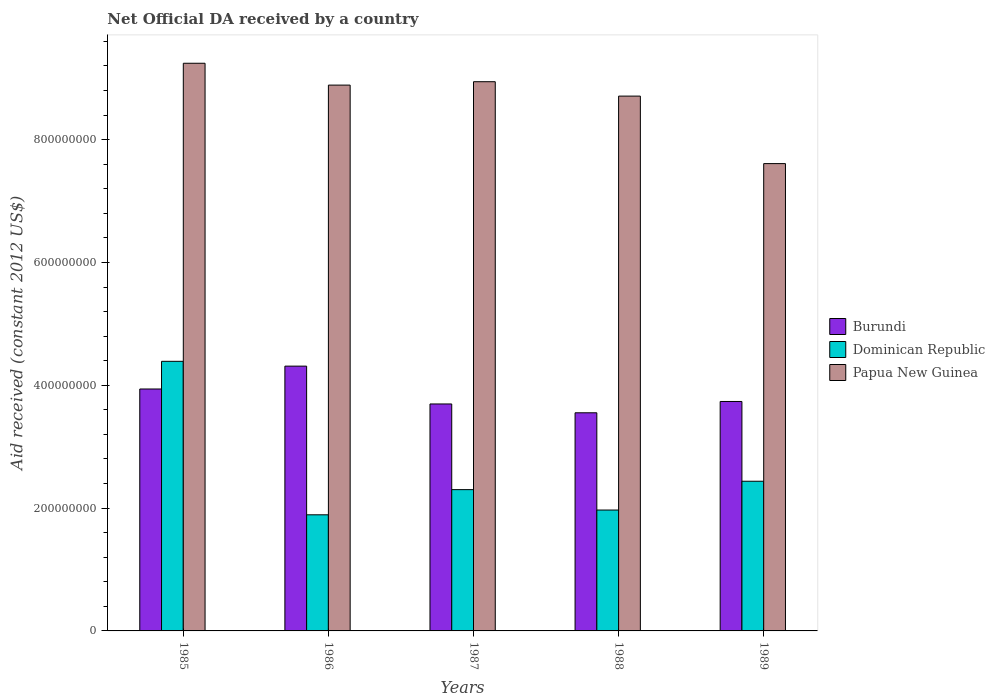How many different coloured bars are there?
Your answer should be compact. 3. How many groups of bars are there?
Provide a succinct answer. 5. How many bars are there on the 5th tick from the right?
Your response must be concise. 3. In how many cases, is the number of bars for a given year not equal to the number of legend labels?
Give a very brief answer. 0. What is the net official development assistance aid received in Dominican Republic in 1987?
Provide a short and direct response. 2.30e+08. Across all years, what is the maximum net official development assistance aid received in Dominican Republic?
Give a very brief answer. 4.39e+08. Across all years, what is the minimum net official development assistance aid received in Papua New Guinea?
Your response must be concise. 7.61e+08. In which year was the net official development assistance aid received in Papua New Guinea maximum?
Offer a terse response. 1985. In which year was the net official development assistance aid received in Dominican Republic minimum?
Keep it short and to the point. 1986. What is the total net official development assistance aid received in Papua New Guinea in the graph?
Your answer should be very brief. 4.34e+09. What is the difference between the net official development assistance aid received in Dominican Republic in 1985 and that in 1989?
Offer a terse response. 1.95e+08. What is the difference between the net official development assistance aid received in Papua New Guinea in 1988 and the net official development assistance aid received in Dominican Republic in 1989?
Provide a succinct answer. 6.27e+08. What is the average net official development assistance aid received in Dominican Republic per year?
Make the answer very short. 2.60e+08. In the year 1989, what is the difference between the net official development assistance aid received in Burundi and net official development assistance aid received in Dominican Republic?
Ensure brevity in your answer.  1.30e+08. What is the ratio of the net official development assistance aid received in Burundi in 1986 to that in 1987?
Your answer should be very brief. 1.17. Is the difference between the net official development assistance aid received in Burundi in 1986 and 1988 greater than the difference between the net official development assistance aid received in Dominican Republic in 1986 and 1988?
Your response must be concise. Yes. What is the difference between the highest and the second highest net official development assistance aid received in Papua New Guinea?
Offer a terse response. 3.00e+07. What is the difference between the highest and the lowest net official development assistance aid received in Dominican Republic?
Give a very brief answer. 2.50e+08. In how many years, is the net official development assistance aid received in Dominican Republic greater than the average net official development assistance aid received in Dominican Republic taken over all years?
Give a very brief answer. 1. What does the 1st bar from the left in 1985 represents?
Make the answer very short. Burundi. What does the 1st bar from the right in 1985 represents?
Offer a very short reply. Papua New Guinea. Is it the case that in every year, the sum of the net official development assistance aid received in Papua New Guinea and net official development assistance aid received in Dominican Republic is greater than the net official development assistance aid received in Burundi?
Give a very brief answer. Yes. How many bars are there?
Make the answer very short. 15. Are all the bars in the graph horizontal?
Your response must be concise. No. What is the difference between two consecutive major ticks on the Y-axis?
Keep it short and to the point. 2.00e+08. Does the graph contain any zero values?
Provide a succinct answer. No. Does the graph contain grids?
Your response must be concise. No. Where does the legend appear in the graph?
Keep it short and to the point. Center right. How are the legend labels stacked?
Offer a terse response. Vertical. What is the title of the graph?
Offer a very short reply. Net Official DA received by a country. What is the label or title of the X-axis?
Make the answer very short. Years. What is the label or title of the Y-axis?
Your answer should be very brief. Aid received (constant 2012 US$). What is the Aid received (constant 2012 US$) in Burundi in 1985?
Your response must be concise. 3.94e+08. What is the Aid received (constant 2012 US$) of Dominican Republic in 1985?
Provide a short and direct response. 4.39e+08. What is the Aid received (constant 2012 US$) of Papua New Guinea in 1985?
Provide a succinct answer. 9.24e+08. What is the Aid received (constant 2012 US$) in Burundi in 1986?
Provide a succinct answer. 4.31e+08. What is the Aid received (constant 2012 US$) in Dominican Republic in 1986?
Offer a terse response. 1.89e+08. What is the Aid received (constant 2012 US$) of Papua New Guinea in 1986?
Your response must be concise. 8.89e+08. What is the Aid received (constant 2012 US$) of Burundi in 1987?
Provide a succinct answer. 3.70e+08. What is the Aid received (constant 2012 US$) of Dominican Republic in 1987?
Make the answer very short. 2.30e+08. What is the Aid received (constant 2012 US$) of Papua New Guinea in 1987?
Provide a short and direct response. 8.94e+08. What is the Aid received (constant 2012 US$) of Burundi in 1988?
Ensure brevity in your answer.  3.55e+08. What is the Aid received (constant 2012 US$) of Dominican Republic in 1988?
Your response must be concise. 1.97e+08. What is the Aid received (constant 2012 US$) of Papua New Guinea in 1988?
Offer a terse response. 8.71e+08. What is the Aid received (constant 2012 US$) in Burundi in 1989?
Keep it short and to the point. 3.74e+08. What is the Aid received (constant 2012 US$) of Dominican Republic in 1989?
Offer a very short reply. 2.44e+08. What is the Aid received (constant 2012 US$) of Papua New Guinea in 1989?
Your answer should be compact. 7.61e+08. Across all years, what is the maximum Aid received (constant 2012 US$) of Burundi?
Your answer should be very brief. 4.31e+08. Across all years, what is the maximum Aid received (constant 2012 US$) in Dominican Republic?
Give a very brief answer. 4.39e+08. Across all years, what is the maximum Aid received (constant 2012 US$) of Papua New Guinea?
Provide a succinct answer. 9.24e+08. Across all years, what is the minimum Aid received (constant 2012 US$) of Burundi?
Your answer should be very brief. 3.55e+08. Across all years, what is the minimum Aid received (constant 2012 US$) of Dominican Republic?
Provide a short and direct response. 1.89e+08. Across all years, what is the minimum Aid received (constant 2012 US$) of Papua New Guinea?
Your response must be concise. 7.61e+08. What is the total Aid received (constant 2012 US$) of Burundi in the graph?
Offer a very short reply. 1.92e+09. What is the total Aid received (constant 2012 US$) of Dominican Republic in the graph?
Provide a succinct answer. 1.30e+09. What is the total Aid received (constant 2012 US$) of Papua New Guinea in the graph?
Ensure brevity in your answer.  4.34e+09. What is the difference between the Aid received (constant 2012 US$) in Burundi in 1985 and that in 1986?
Offer a terse response. -3.72e+07. What is the difference between the Aid received (constant 2012 US$) of Dominican Republic in 1985 and that in 1986?
Your answer should be compact. 2.50e+08. What is the difference between the Aid received (constant 2012 US$) in Papua New Guinea in 1985 and that in 1986?
Give a very brief answer. 3.56e+07. What is the difference between the Aid received (constant 2012 US$) in Burundi in 1985 and that in 1987?
Make the answer very short. 2.44e+07. What is the difference between the Aid received (constant 2012 US$) in Dominican Republic in 1985 and that in 1987?
Your answer should be very brief. 2.09e+08. What is the difference between the Aid received (constant 2012 US$) in Papua New Guinea in 1985 and that in 1987?
Offer a very short reply. 3.00e+07. What is the difference between the Aid received (constant 2012 US$) of Burundi in 1985 and that in 1988?
Keep it short and to the point. 3.87e+07. What is the difference between the Aid received (constant 2012 US$) of Dominican Republic in 1985 and that in 1988?
Offer a terse response. 2.42e+08. What is the difference between the Aid received (constant 2012 US$) of Papua New Guinea in 1985 and that in 1988?
Provide a succinct answer. 5.35e+07. What is the difference between the Aid received (constant 2012 US$) of Burundi in 1985 and that in 1989?
Provide a succinct answer. 2.03e+07. What is the difference between the Aid received (constant 2012 US$) of Dominican Republic in 1985 and that in 1989?
Your response must be concise. 1.95e+08. What is the difference between the Aid received (constant 2012 US$) of Papua New Guinea in 1985 and that in 1989?
Your answer should be very brief. 1.63e+08. What is the difference between the Aid received (constant 2012 US$) of Burundi in 1986 and that in 1987?
Your answer should be very brief. 6.16e+07. What is the difference between the Aid received (constant 2012 US$) of Dominican Republic in 1986 and that in 1987?
Offer a very short reply. -4.10e+07. What is the difference between the Aid received (constant 2012 US$) in Papua New Guinea in 1986 and that in 1987?
Your answer should be very brief. -5.53e+06. What is the difference between the Aid received (constant 2012 US$) in Burundi in 1986 and that in 1988?
Your answer should be compact. 7.60e+07. What is the difference between the Aid received (constant 2012 US$) in Dominican Republic in 1986 and that in 1988?
Offer a terse response. -7.77e+06. What is the difference between the Aid received (constant 2012 US$) in Papua New Guinea in 1986 and that in 1988?
Provide a short and direct response. 1.79e+07. What is the difference between the Aid received (constant 2012 US$) of Burundi in 1986 and that in 1989?
Provide a succinct answer. 5.76e+07. What is the difference between the Aid received (constant 2012 US$) of Dominican Republic in 1986 and that in 1989?
Provide a short and direct response. -5.47e+07. What is the difference between the Aid received (constant 2012 US$) in Papua New Guinea in 1986 and that in 1989?
Offer a terse response. 1.28e+08. What is the difference between the Aid received (constant 2012 US$) of Burundi in 1987 and that in 1988?
Provide a short and direct response. 1.44e+07. What is the difference between the Aid received (constant 2012 US$) in Dominican Republic in 1987 and that in 1988?
Keep it short and to the point. 3.32e+07. What is the difference between the Aid received (constant 2012 US$) of Papua New Guinea in 1987 and that in 1988?
Make the answer very short. 2.34e+07. What is the difference between the Aid received (constant 2012 US$) of Burundi in 1987 and that in 1989?
Keep it short and to the point. -4.06e+06. What is the difference between the Aid received (constant 2012 US$) in Dominican Republic in 1987 and that in 1989?
Offer a very short reply. -1.37e+07. What is the difference between the Aid received (constant 2012 US$) of Papua New Guinea in 1987 and that in 1989?
Your answer should be compact. 1.33e+08. What is the difference between the Aid received (constant 2012 US$) of Burundi in 1988 and that in 1989?
Offer a very short reply. -1.84e+07. What is the difference between the Aid received (constant 2012 US$) in Dominican Republic in 1988 and that in 1989?
Offer a terse response. -4.69e+07. What is the difference between the Aid received (constant 2012 US$) in Papua New Guinea in 1988 and that in 1989?
Offer a terse response. 1.10e+08. What is the difference between the Aid received (constant 2012 US$) of Burundi in 1985 and the Aid received (constant 2012 US$) of Dominican Republic in 1986?
Keep it short and to the point. 2.05e+08. What is the difference between the Aid received (constant 2012 US$) of Burundi in 1985 and the Aid received (constant 2012 US$) of Papua New Guinea in 1986?
Keep it short and to the point. -4.95e+08. What is the difference between the Aid received (constant 2012 US$) of Dominican Republic in 1985 and the Aid received (constant 2012 US$) of Papua New Guinea in 1986?
Ensure brevity in your answer.  -4.50e+08. What is the difference between the Aid received (constant 2012 US$) of Burundi in 1985 and the Aid received (constant 2012 US$) of Dominican Republic in 1987?
Your answer should be compact. 1.64e+08. What is the difference between the Aid received (constant 2012 US$) of Burundi in 1985 and the Aid received (constant 2012 US$) of Papua New Guinea in 1987?
Keep it short and to the point. -5.00e+08. What is the difference between the Aid received (constant 2012 US$) of Dominican Republic in 1985 and the Aid received (constant 2012 US$) of Papua New Guinea in 1987?
Offer a terse response. -4.55e+08. What is the difference between the Aid received (constant 2012 US$) in Burundi in 1985 and the Aid received (constant 2012 US$) in Dominican Republic in 1988?
Keep it short and to the point. 1.97e+08. What is the difference between the Aid received (constant 2012 US$) in Burundi in 1985 and the Aid received (constant 2012 US$) in Papua New Guinea in 1988?
Provide a short and direct response. -4.77e+08. What is the difference between the Aid received (constant 2012 US$) in Dominican Republic in 1985 and the Aid received (constant 2012 US$) in Papua New Guinea in 1988?
Give a very brief answer. -4.32e+08. What is the difference between the Aid received (constant 2012 US$) of Burundi in 1985 and the Aid received (constant 2012 US$) of Dominican Republic in 1989?
Your response must be concise. 1.50e+08. What is the difference between the Aid received (constant 2012 US$) in Burundi in 1985 and the Aid received (constant 2012 US$) in Papua New Guinea in 1989?
Provide a succinct answer. -3.67e+08. What is the difference between the Aid received (constant 2012 US$) in Dominican Republic in 1985 and the Aid received (constant 2012 US$) in Papua New Guinea in 1989?
Keep it short and to the point. -3.22e+08. What is the difference between the Aid received (constant 2012 US$) of Burundi in 1986 and the Aid received (constant 2012 US$) of Dominican Republic in 1987?
Make the answer very short. 2.01e+08. What is the difference between the Aid received (constant 2012 US$) in Burundi in 1986 and the Aid received (constant 2012 US$) in Papua New Guinea in 1987?
Give a very brief answer. -4.63e+08. What is the difference between the Aid received (constant 2012 US$) in Dominican Republic in 1986 and the Aid received (constant 2012 US$) in Papua New Guinea in 1987?
Ensure brevity in your answer.  -7.05e+08. What is the difference between the Aid received (constant 2012 US$) of Burundi in 1986 and the Aid received (constant 2012 US$) of Dominican Republic in 1988?
Offer a very short reply. 2.34e+08. What is the difference between the Aid received (constant 2012 US$) of Burundi in 1986 and the Aid received (constant 2012 US$) of Papua New Guinea in 1988?
Offer a terse response. -4.40e+08. What is the difference between the Aid received (constant 2012 US$) in Dominican Republic in 1986 and the Aid received (constant 2012 US$) in Papua New Guinea in 1988?
Keep it short and to the point. -6.82e+08. What is the difference between the Aid received (constant 2012 US$) of Burundi in 1986 and the Aid received (constant 2012 US$) of Dominican Republic in 1989?
Provide a succinct answer. 1.87e+08. What is the difference between the Aid received (constant 2012 US$) in Burundi in 1986 and the Aid received (constant 2012 US$) in Papua New Guinea in 1989?
Your answer should be compact. -3.30e+08. What is the difference between the Aid received (constant 2012 US$) of Dominican Republic in 1986 and the Aid received (constant 2012 US$) of Papua New Guinea in 1989?
Offer a terse response. -5.72e+08. What is the difference between the Aid received (constant 2012 US$) in Burundi in 1987 and the Aid received (constant 2012 US$) in Dominican Republic in 1988?
Keep it short and to the point. 1.73e+08. What is the difference between the Aid received (constant 2012 US$) of Burundi in 1987 and the Aid received (constant 2012 US$) of Papua New Guinea in 1988?
Keep it short and to the point. -5.01e+08. What is the difference between the Aid received (constant 2012 US$) in Dominican Republic in 1987 and the Aid received (constant 2012 US$) in Papua New Guinea in 1988?
Provide a succinct answer. -6.41e+08. What is the difference between the Aid received (constant 2012 US$) of Burundi in 1987 and the Aid received (constant 2012 US$) of Dominican Republic in 1989?
Keep it short and to the point. 1.26e+08. What is the difference between the Aid received (constant 2012 US$) in Burundi in 1987 and the Aid received (constant 2012 US$) in Papua New Guinea in 1989?
Provide a succinct answer. -3.91e+08. What is the difference between the Aid received (constant 2012 US$) in Dominican Republic in 1987 and the Aid received (constant 2012 US$) in Papua New Guinea in 1989?
Your answer should be compact. -5.31e+08. What is the difference between the Aid received (constant 2012 US$) in Burundi in 1988 and the Aid received (constant 2012 US$) in Dominican Republic in 1989?
Your answer should be compact. 1.11e+08. What is the difference between the Aid received (constant 2012 US$) of Burundi in 1988 and the Aid received (constant 2012 US$) of Papua New Guinea in 1989?
Your answer should be very brief. -4.06e+08. What is the difference between the Aid received (constant 2012 US$) of Dominican Republic in 1988 and the Aid received (constant 2012 US$) of Papua New Guinea in 1989?
Your response must be concise. -5.64e+08. What is the average Aid received (constant 2012 US$) in Burundi per year?
Provide a succinct answer. 3.85e+08. What is the average Aid received (constant 2012 US$) in Dominican Republic per year?
Provide a short and direct response. 2.60e+08. What is the average Aid received (constant 2012 US$) of Papua New Guinea per year?
Offer a very short reply. 8.68e+08. In the year 1985, what is the difference between the Aid received (constant 2012 US$) of Burundi and Aid received (constant 2012 US$) of Dominican Republic?
Provide a succinct answer. -4.50e+07. In the year 1985, what is the difference between the Aid received (constant 2012 US$) in Burundi and Aid received (constant 2012 US$) in Papua New Guinea?
Provide a short and direct response. -5.30e+08. In the year 1985, what is the difference between the Aid received (constant 2012 US$) in Dominican Republic and Aid received (constant 2012 US$) in Papua New Guinea?
Your response must be concise. -4.85e+08. In the year 1986, what is the difference between the Aid received (constant 2012 US$) of Burundi and Aid received (constant 2012 US$) of Dominican Republic?
Your response must be concise. 2.42e+08. In the year 1986, what is the difference between the Aid received (constant 2012 US$) in Burundi and Aid received (constant 2012 US$) in Papua New Guinea?
Your answer should be compact. -4.58e+08. In the year 1986, what is the difference between the Aid received (constant 2012 US$) in Dominican Republic and Aid received (constant 2012 US$) in Papua New Guinea?
Give a very brief answer. -7.00e+08. In the year 1987, what is the difference between the Aid received (constant 2012 US$) in Burundi and Aid received (constant 2012 US$) in Dominican Republic?
Offer a terse response. 1.40e+08. In the year 1987, what is the difference between the Aid received (constant 2012 US$) of Burundi and Aid received (constant 2012 US$) of Papua New Guinea?
Offer a very short reply. -5.25e+08. In the year 1987, what is the difference between the Aid received (constant 2012 US$) of Dominican Republic and Aid received (constant 2012 US$) of Papua New Guinea?
Provide a succinct answer. -6.64e+08. In the year 1988, what is the difference between the Aid received (constant 2012 US$) of Burundi and Aid received (constant 2012 US$) of Dominican Republic?
Offer a terse response. 1.58e+08. In the year 1988, what is the difference between the Aid received (constant 2012 US$) in Burundi and Aid received (constant 2012 US$) in Papua New Guinea?
Your answer should be compact. -5.16e+08. In the year 1988, what is the difference between the Aid received (constant 2012 US$) of Dominican Republic and Aid received (constant 2012 US$) of Papua New Guinea?
Ensure brevity in your answer.  -6.74e+08. In the year 1989, what is the difference between the Aid received (constant 2012 US$) in Burundi and Aid received (constant 2012 US$) in Dominican Republic?
Make the answer very short. 1.30e+08. In the year 1989, what is the difference between the Aid received (constant 2012 US$) of Burundi and Aid received (constant 2012 US$) of Papua New Guinea?
Your answer should be very brief. -3.87e+08. In the year 1989, what is the difference between the Aid received (constant 2012 US$) of Dominican Republic and Aid received (constant 2012 US$) of Papua New Guinea?
Make the answer very short. -5.17e+08. What is the ratio of the Aid received (constant 2012 US$) of Burundi in 1985 to that in 1986?
Keep it short and to the point. 0.91. What is the ratio of the Aid received (constant 2012 US$) in Dominican Republic in 1985 to that in 1986?
Make the answer very short. 2.32. What is the ratio of the Aid received (constant 2012 US$) of Burundi in 1985 to that in 1987?
Keep it short and to the point. 1.07. What is the ratio of the Aid received (constant 2012 US$) of Dominican Republic in 1985 to that in 1987?
Make the answer very short. 1.91. What is the ratio of the Aid received (constant 2012 US$) of Papua New Guinea in 1985 to that in 1987?
Your answer should be compact. 1.03. What is the ratio of the Aid received (constant 2012 US$) of Burundi in 1985 to that in 1988?
Your answer should be compact. 1.11. What is the ratio of the Aid received (constant 2012 US$) in Dominican Republic in 1985 to that in 1988?
Your answer should be very brief. 2.23. What is the ratio of the Aid received (constant 2012 US$) in Papua New Guinea in 1985 to that in 1988?
Offer a very short reply. 1.06. What is the ratio of the Aid received (constant 2012 US$) in Burundi in 1985 to that in 1989?
Offer a terse response. 1.05. What is the ratio of the Aid received (constant 2012 US$) in Dominican Republic in 1985 to that in 1989?
Make the answer very short. 1.8. What is the ratio of the Aid received (constant 2012 US$) in Papua New Guinea in 1985 to that in 1989?
Your response must be concise. 1.21. What is the ratio of the Aid received (constant 2012 US$) in Burundi in 1986 to that in 1987?
Keep it short and to the point. 1.17. What is the ratio of the Aid received (constant 2012 US$) of Dominican Republic in 1986 to that in 1987?
Your answer should be very brief. 0.82. What is the ratio of the Aid received (constant 2012 US$) of Burundi in 1986 to that in 1988?
Your answer should be compact. 1.21. What is the ratio of the Aid received (constant 2012 US$) of Dominican Republic in 1986 to that in 1988?
Provide a succinct answer. 0.96. What is the ratio of the Aid received (constant 2012 US$) in Papua New Guinea in 1986 to that in 1988?
Offer a very short reply. 1.02. What is the ratio of the Aid received (constant 2012 US$) of Burundi in 1986 to that in 1989?
Offer a terse response. 1.15. What is the ratio of the Aid received (constant 2012 US$) in Dominican Republic in 1986 to that in 1989?
Provide a succinct answer. 0.78. What is the ratio of the Aid received (constant 2012 US$) of Papua New Guinea in 1986 to that in 1989?
Offer a terse response. 1.17. What is the ratio of the Aid received (constant 2012 US$) of Burundi in 1987 to that in 1988?
Make the answer very short. 1.04. What is the ratio of the Aid received (constant 2012 US$) in Dominican Republic in 1987 to that in 1988?
Offer a very short reply. 1.17. What is the ratio of the Aid received (constant 2012 US$) in Papua New Guinea in 1987 to that in 1988?
Offer a terse response. 1.03. What is the ratio of the Aid received (constant 2012 US$) in Dominican Republic in 1987 to that in 1989?
Offer a very short reply. 0.94. What is the ratio of the Aid received (constant 2012 US$) in Papua New Guinea in 1987 to that in 1989?
Ensure brevity in your answer.  1.18. What is the ratio of the Aid received (constant 2012 US$) in Burundi in 1988 to that in 1989?
Give a very brief answer. 0.95. What is the ratio of the Aid received (constant 2012 US$) in Dominican Republic in 1988 to that in 1989?
Make the answer very short. 0.81. What is the ratio of the Aid received (constant 2012 US$) in Papua New Guinea in 1988 to that in 1989?
Give a very brief answer. 1.14. What is the difference between the highest and the second highest Aid received (constant 2012 US$) of Burundi?
Offer a very short reply. 3.72e+07. What is the difference between the highest and the second highest Aid received (constant 2012 US$) of Dominican Republic?
Provide a short and direct response. 1.95e+08. What is the difference between the highest and the second highest Aid received (constant 2012 US$) in Papua New Guinea?
Your answer should be compact. 3.00e+07. What is the difference between the highest and the lowest Aid received (constant 2012 US$) of Burundi?
Provide a short and direct response. 7.60e+07. What is the difference between the highest and the lowest Aid received (constant 2012 US$) in Dominican Republic?
Keep it short and to the point. 2.50e+08. What is the difference between the highest and the lowest Aid received (constant 2012 US$) of Papua New Guinea?
Provide a succinct answer. 1.63e+08. 